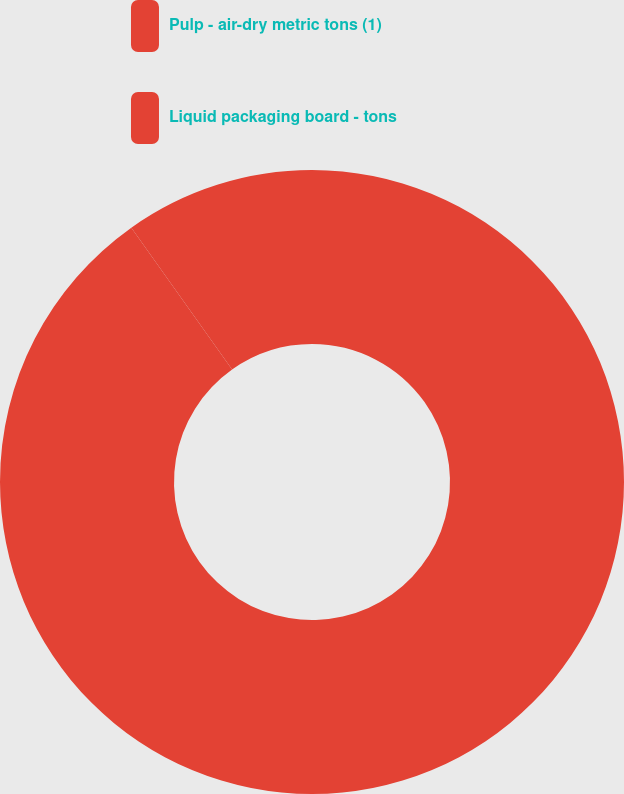Convert chart. <chart><loc_0><loc_0><loc_500><loc_500><pie_chart><fcel>Pulp - air-dry metric tons (1)<fcel>Liquid packaging board - tons<nl><fcel>90.17%<fcel>9.83%<nl></chart> 